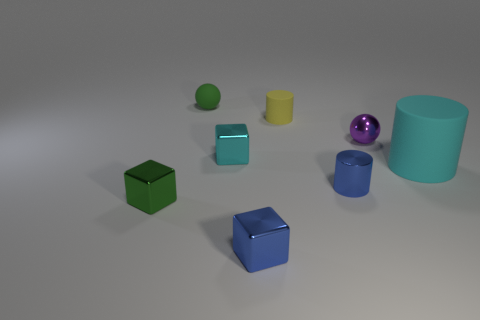Subtract all red cylinders. Subtract all green blocks. How many cylinders are left? 3 Add 1 small green rubber cubes. How many objects exist? 9 Subtract all spheres. How many objects are left? 6 Add 8 big cylinders. How many big cylinders exist? 9 Subtract 0 purple cylinders. How many objects are left? 8 Subtract all tiny blue metallic cylinders. Subtract all big brown spheres. How many objects are left? 7 Add 4 purple metal spheres. How many purple metal spheres are left? 5 